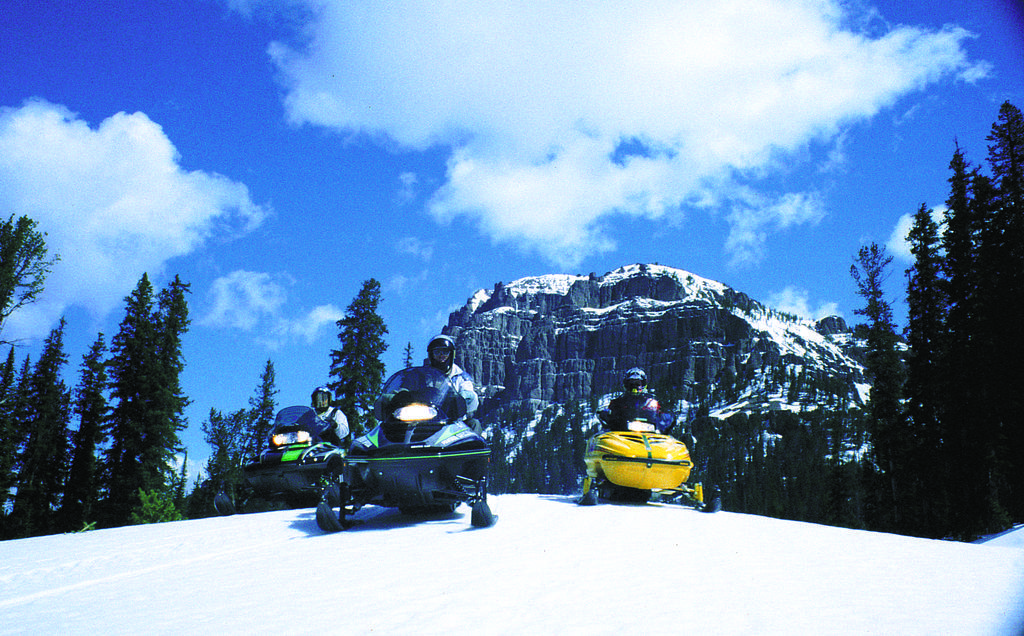Can you describe this image briefly? In this image, there is an outside view. There are three persons wearing helmets and sitting in vehicles. There is a hill in the middle of the image. There are some trees on the left and on the right side of the image. In the background, there is a sky. 